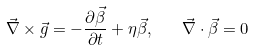<formula> <loc_0><loc_0><loc_500><loc_500>\vec { \nabla } \times \vec { g } = - \frac { \partial \vec { \beta } } { \partial t } + \eta \vec { \beta } , \quad \vec { \nabla } \cdot \vec { \beta } = 0</formula> 